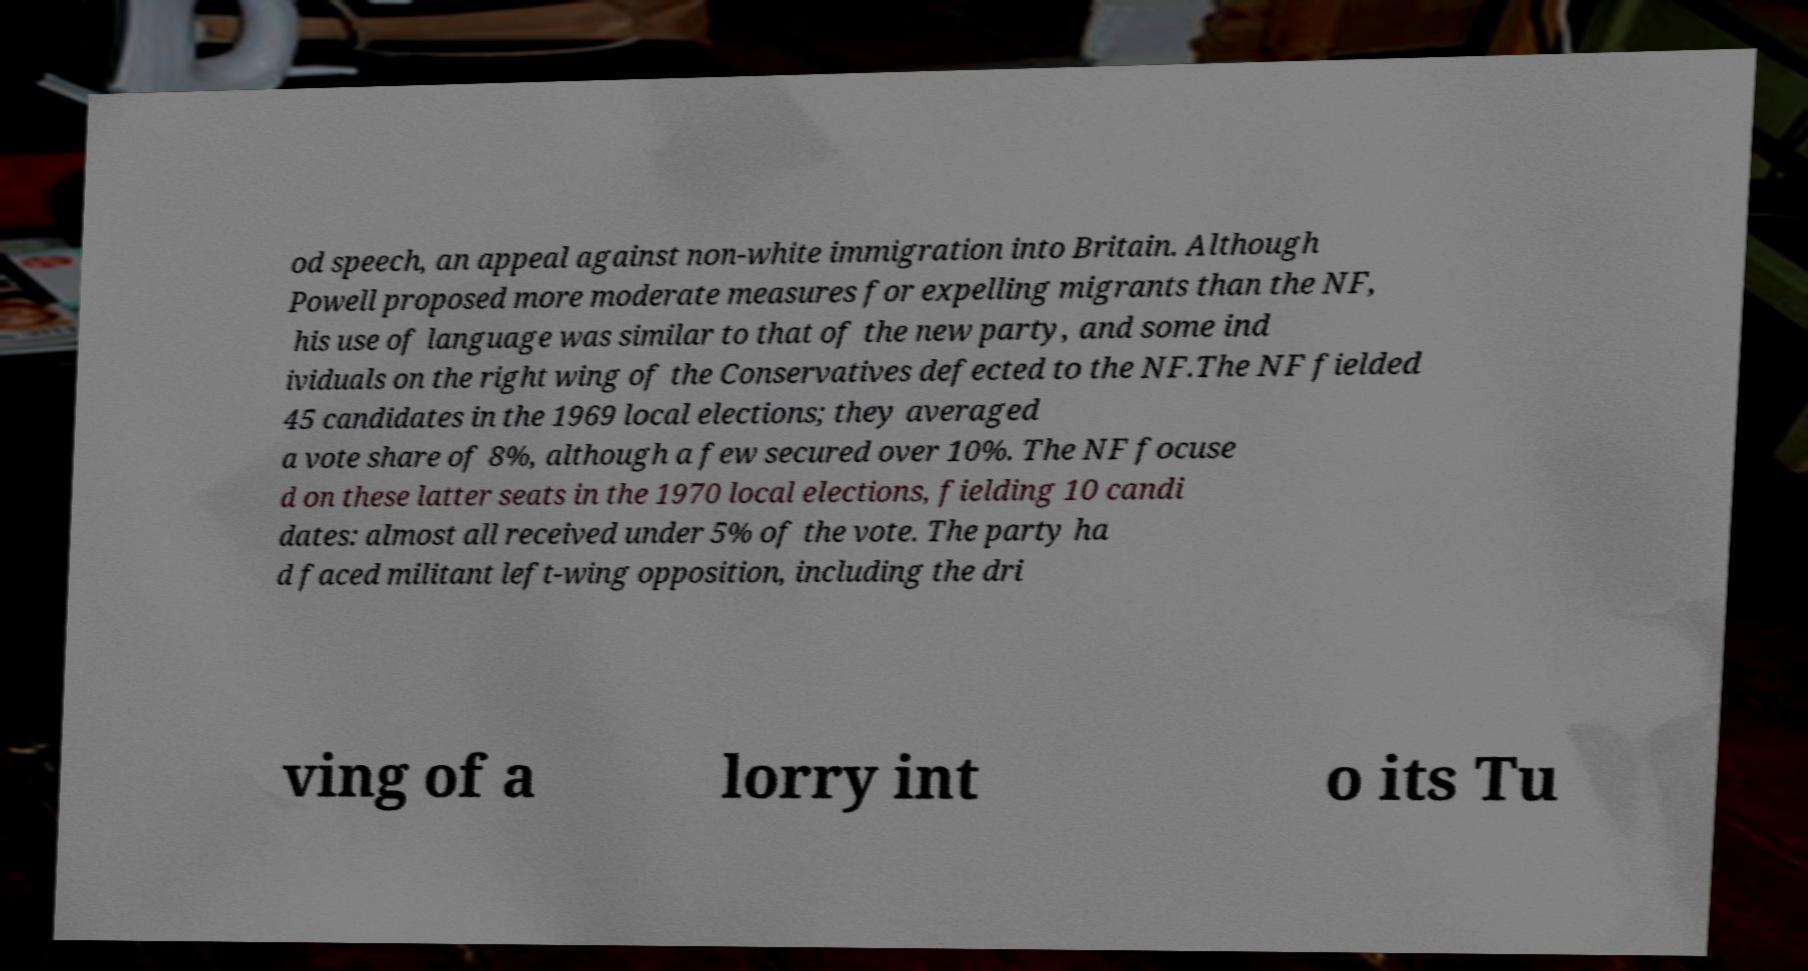Please read and relay the text visible in this image. What does it say? od speech, an appeal against non-white immigration into Britain. Although Powell proposed more moderate measures for expelling migrants than the NF, his use of language was similar to that of the new party, and some ind ividuals on the right wing of the Conservatives defected to the NF.The NF fielded 45 candidates in the 1969 local elections; they averaged a vote share of 8%, although a few secured over 10%. The NF focuse d on these latter seats in the 1970 local elections, fielding 10 candi dates: almost all received under 5% of the vote. The party ha d faced militant left-wing opposition, including the dri ving of a lorry int o its Tu 